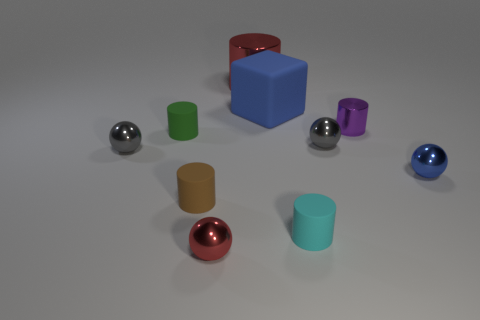How many things are purple balls or purple cylinders?
Make the answer very short. 1. Is there any other thing that has the same color as the large matte thing?
Offer a terse response. Yes. Are the cyan thing and the cube that is right of the tiny brown cylinder made of the same material?
Provide a succinct answer. Yes. There is a red thing behind the metal thing that is in front of the blue metallic ball; what is its shape?
Your answer should be compact. Cylinder. There is a small object that is on the left side of the purple thing and to the right of the tiny cyan matte cylinder; what shape is it?
Offer a terse response. Sphere. How many objects are either small gray shiny balls or shiny objects that are left of the tiny cyan object?
Your response must be concise. 4. What is the material of the large red object that is the same shape as the purple thing?
Your answer should be compact. Metal. Is there anything else that has the same material as the brown cylinder?
Give a very brief answer. Yes. There is a object that is in front of the brown cylinder and behind the small red metal ball; what material is it?
Ensure brevity in your answer.  Rubber. How many blue objects are the same shape as the purple thing?
Provide a succinct answer. 0. 